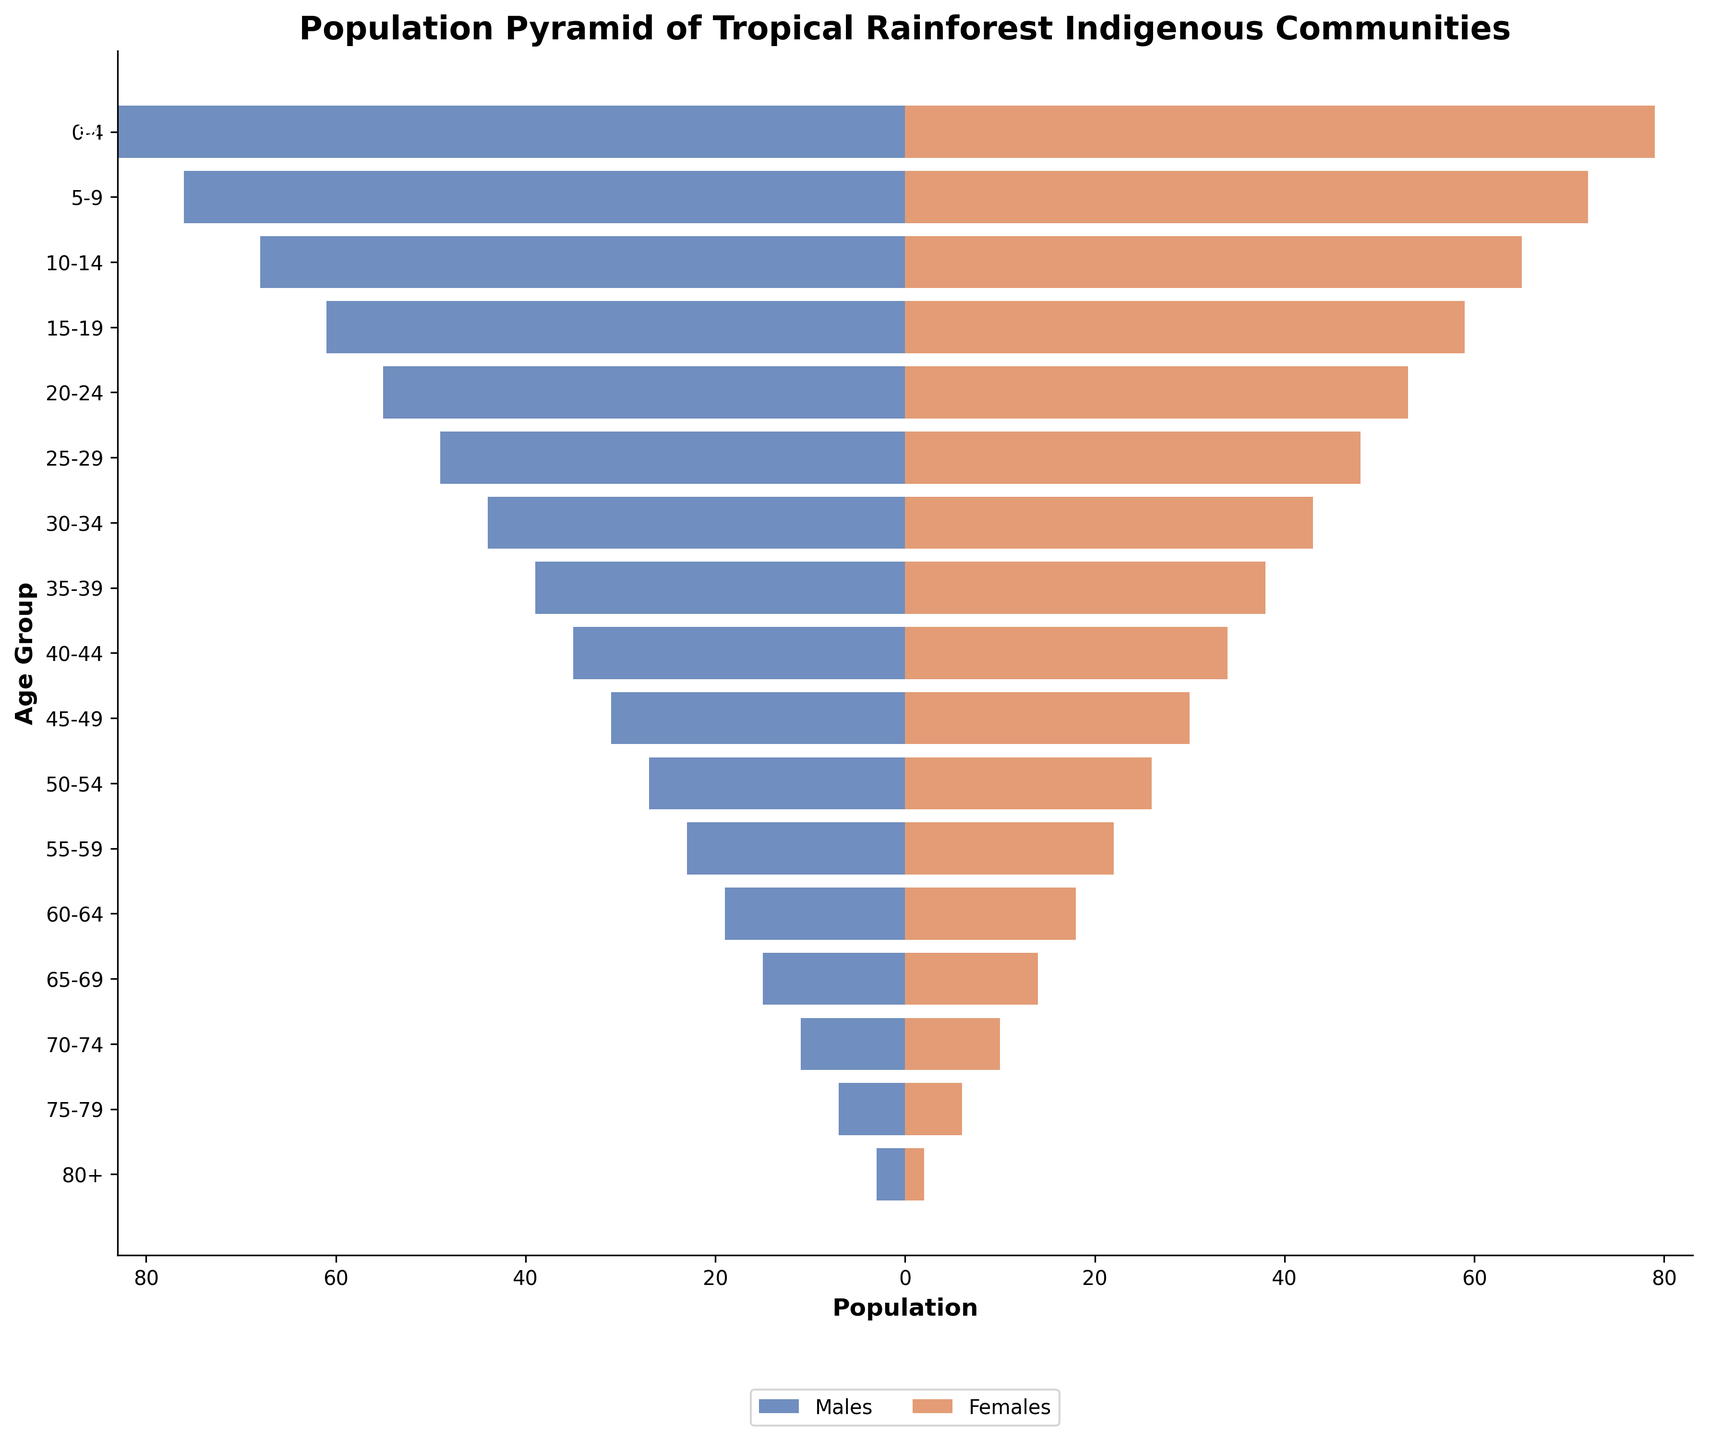What is the title of the plotted figure? The title is written at the top of the figure in a larger, bold font. It gives a concise description of what the plot represents.
Answer: Population Pyramid of Tropical Rainforest Indigenous Communities What does the horizontal axis represent? The horizontal axis is labeled with a description under the plot in bold. It shows the value each bar represents.
Answer: Population Which age group has the highest male population? Identify the age group with the longest bar extending to the left (negative side) representing males.
Answer: 0-4 What is the population of females in the 20-24 age group? Locate the bar corresponding to the 20-24 age group on the right side (positive side). Read the value annotated next to it.
Answer: 53 How many females are in the age group 50-54? Look at the positive bar next to the 50-54 age group and read the number at the end of the bar.
Answer: 26 How does the male population in the 5-9 age group compare to the female population in the same group? Find the lengths of both the male and female bars for this age group. Compare the magnitude of the values.
Answer: 76 males, 72 females Which gender has a higher population in the 75-79 age group? Compare the lengths of the bars representing males and females for the 75-79 age group. The longer bar indicates the greater population.
Answer: Males What is the sum of the male and female populations in the 65-69 age group? Find the absolute values of the male and female populations for this age group and add them together.
Answer: 29 Is there an age group where the male population exactly equals the female population? Compare the values of all the age groups for both males and females.
Answer: No What's the difference between the male and female populations in the 15-19 age group? Find the values for males and females in this age group, subtract the smaller value from the larger value.
Answer: 2 